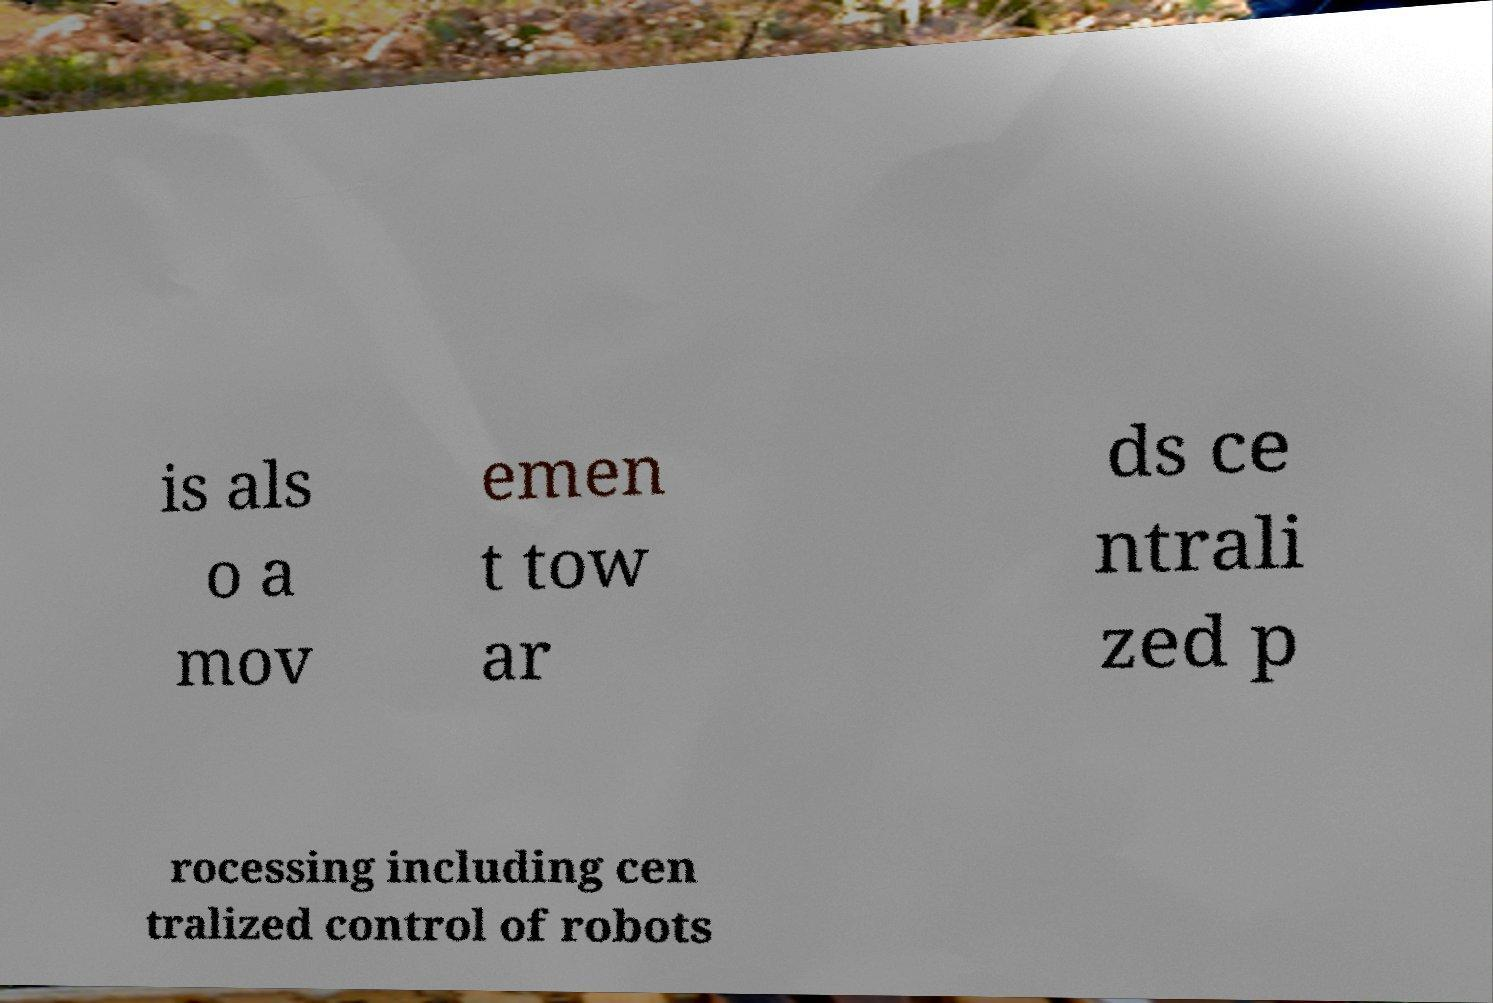I need the written content from this picture converted into text. Can you do that? is als o a mov emen t tow ar ds ce ntrali zed p rocessing including cen tralized control of robots 